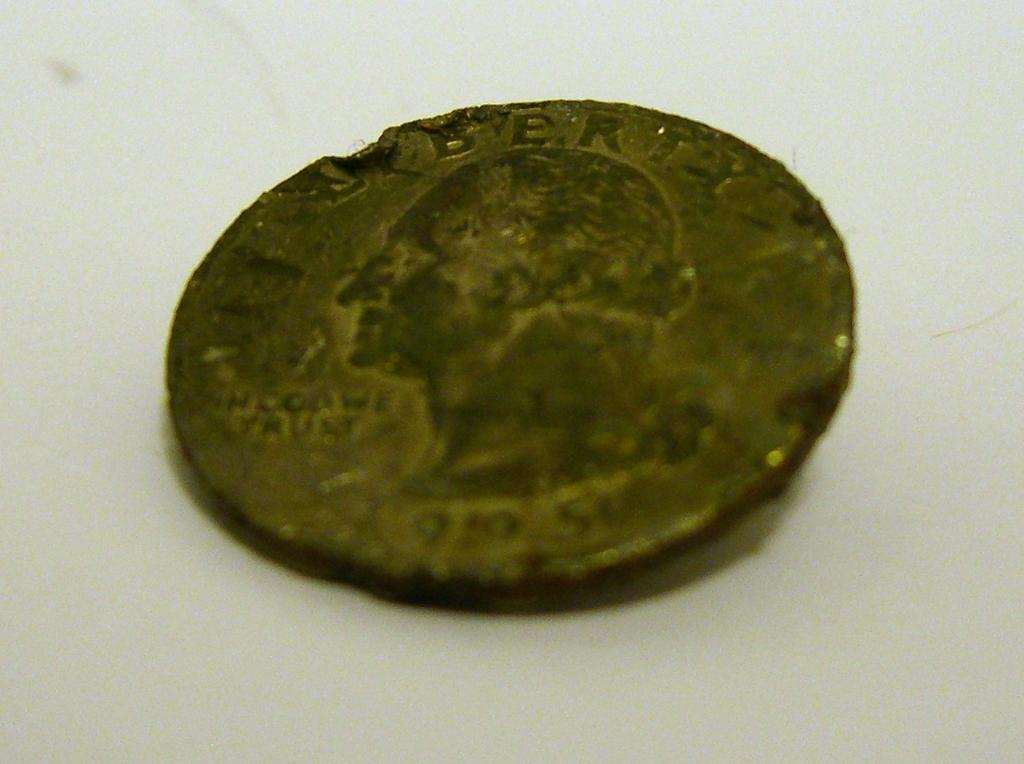<image>
Present a compact description of the photo's key features. A tarnished quarter with the "i" in liberty missing from the top. 